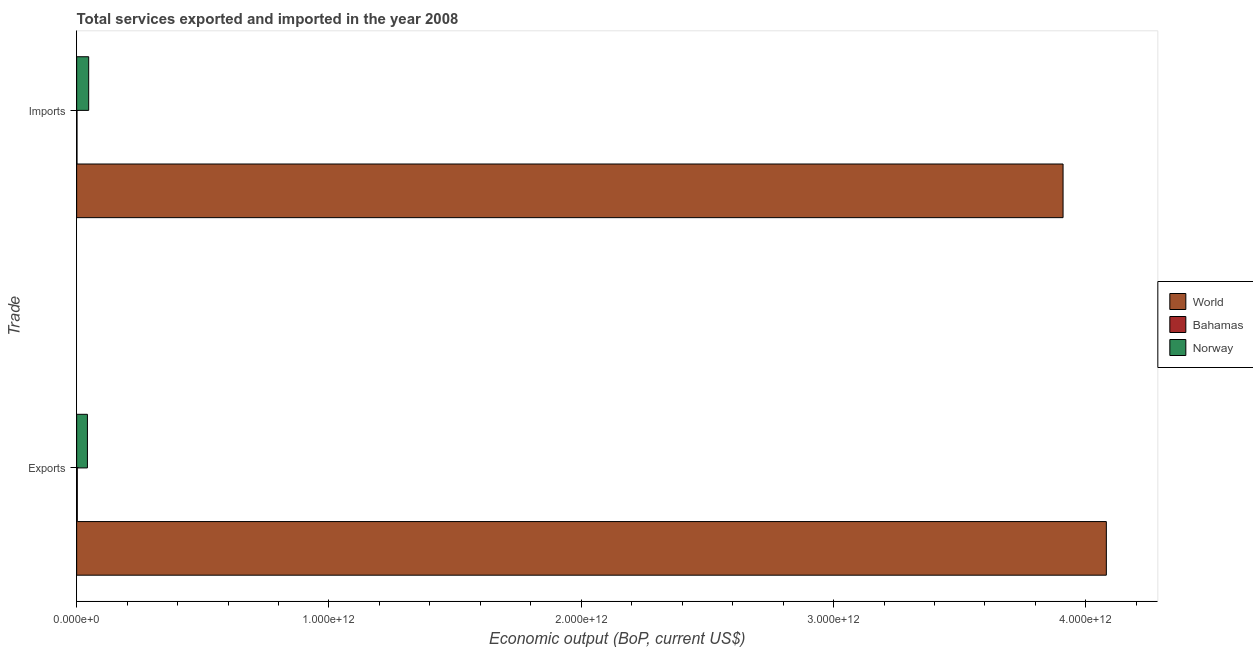Are the number of bars per tick equal to the number of legend labels?
Offer a very short reply. Yes. How many bars are there on the 2nd tick from the top?
Ensure brevity in your answer.  3. How many bars are there on the 2nd tick from the bottom?
Your answer should be compact. 3. What is the label of the 2nd group of bars from the top?
Offer a very short reply. Exports. What is the amount of service exports in World?
Your response must be concise. 4.08e+12. Across all countries, what is the maximum amount of service imports?
Your answer should be very brief. 3.91e+12. Across all countries, what is the minimum amount of service exports?
Offer a very short reply. 2.53e+09. In which country was the amount of service imports minimum?
Make the answer very short. Bahamas. What is the total amount of service exports in the graph?
Your response must be concise. 4.13e+12. What is the difference between the amount of service imports in Bahamas and that in World?
Provide a succinct answer. -3.91e+12. What is the difference between the amount of service exports in Bahamas and the amount of service imports in World?
Keep it short and to the point. -3.91e+12. What is the average amount of service imports per country?
Offer a very short reply. 1.32e+12. What is the difference between the amount of service exports and amount of service imports in Norway?
Your response must be concise. -5.07e+09. In how many countries, is the amount of service exports greater than 2800000000000 US$?
Your answer should be very brief. 1. What is the ratio of the amount of service exports in Norway to that in World?
Ensure brevity in your answer.  0.01. What does the 3rd bar from the top in Imports represents?
Offer a terse response. World. How many bars are there?
Your answer should be compact. 6. What is the difference between two consecutive major ticks on the X-axis?
Your answer should be very brief. 1.00e+12. Are the values on the major ticks of X-axis written in scientific E-notation?
Your answer should be compact. Yes. Does the graph contain grids?
Ensure brevity in your answer.  No. How many legend labels are there?
Make the answer very short. 3. How are the legend labels stacked?
Make the answer very short. Vertical. What is the title of the graph?
Provide a short and direct response. Total services exported and imported in the year 2008. Does "Montenegro" appear as one of the legend labels in the graph?
Your answer should be compact. No. What is the label or title of the X-axis?
Keep it short and to the point. Economic output (BoP, current US$). What is the label or title of the Y-axis?
Keep it short and to the point. Trade. What is the Economic output (BoP, current US$) in World in Exports?
Your response must be concise. 4.08e+12. What is the Economic output (BoP, current US$) of Bahamas in Exports?
Keep it short and to the point. 2.53e+09. What is the Economic output (BoP, current US$) of Norway in Exports?
Offer a very short reply. 4.26e+1. What is the Economic output (BoP, current US$) of World in Imports?
Your answer should be compact. 3.91e+12. What is the Economic output (BoP, current US$) in Bahamas in Imports?
Make the answer very short. 1.40e+09. What is the Economic output (BoP, current US$) of Norway in Imports?
Offer a terse response. 4.77e+1. Across all Trade, what is the maximum Economic output (BoP, current US$) of World?
Keep it short and to the point. 4.08e+12. Across all Trade, what is the maximum Economic output (BoP, current US$) of Bahamas?
Your answer should be very brief. 2.53e+09. Across all Trade, what is the maximum Economic output (BoP, current US$) in Norway?
Your answer should be very brief. 4.77e+1. Across all Trade, what is the minimum Economic output (BoP, current US$) in World?
Give a very brief answer. 3.91e+12. Across all Trade, what is the minimum Economic output (BoP, current US$) of Bahamas?
Make the answer very short. 1.40e+09. Across all Trade, what is the minimum Economic output (BoP, current US$) of Norway?
Offer a terse response. 4.26e+1. What is the total Economic output (BoP, current US$) in World in the graph?
Keep it short and to the point. 7.99e+12. What is the total Economic output (BoP, current US$) of Bahamas in the graph?
Offer a very short reply. 3.94e+09. What is the total Economic output (BoP, current US$) of Norway in the graph?
Offer a very short reply. 9.03e+1. What is the difference between the Economic output (BoP, current US$) of World in Exports and that in Imports?
Give a very brief answer. 1.72e+11. What is the difference between the Economic output (BoP, current US$) of Bahamas in Exports and that in Imports?
Ensure brevity in your answer.  1.13e+09. What is the difference between the Economic output (BoP, current US$) of Norway in Exports and that in Imports?
Offer a very short reply. -5.07e+09. What is the difference between the Economic output (BoP, current US$) in World in Exports and the Economic output (BoP, current US$) in Bahamas in Imports?
Keep it short and to the point. 4.08e+12. What is the difference between the Economic output (BoP, current US$) in World in Exports and the Economic output (BoP, current US$) in Norway in Imports?
Make the answer very short. 4.03e+12. What is the difference between the Economic output (BoP, current US$) of Bahamas in Exports and the Economic output (BoP, current US$) of Norway in Imports?
Provide a short and direct response. -4.52e+1. What is the average Economic output (BoP, current US$) of World per Trade?
Ensure brevity in your answer.  4.00e+12. What is the average Economic output (BoP, current US$) in Bahamas per Trade?
Keep it short and to the point. 1.97e+09. What is the average Economic output (BoP, current US$) in Norway per Trade?
Ensure brevity in your answer.  4.52e+1. What is the difference between the Economic output (BoP, current US$) in World and Economic output (BoP, current US$) in Bahamas in Exports?
Offer a very short reply. 4.08e+12. What is the difference between the Economic output (BoP, current US$) in World and Economic output (BoP, current US$) in Norway in Exports?
Ensure brevity in your answer.  4.04e+12. What is the difference between the Economic output (BoP, current US$) of Bahamas and Economic output (BoP, current US$) of Norway in Exports?
Give a very brief answer. -4.01e+1. What is the difference between the Economic output (BoP, current US$) in World and Economic output (BoP, current US$) in Bahamas in Imports?
Your answer should be very brief. 3.91e+12. What is the difference between the Economic output (BoP, current US$) in World and Economic output (BoP, current US$) in Norway in Imports?
Make the answer very short. 3.86e+12. What is the difference between the Economic output (BoP, current US$) in Bahamas and Economic output (BoP, current US$) in Norway in Imports?
Your answer should be very brief. -4.63e+1. What is the ratio of the Economic output (BoP, current US$) of World in Exports to that in Imports?
Offer a terse response. 1.04. What is the ratio of the Economic output (BoP, current US$) in Bahamas in Exports to that in Imports?
Your response must be concise. 1.81. What is the ratio of the Economic output (BoP, current US$) in Norway in Exports to that in Imports?
Provide a succinct answer. 0.89. What is the difference between the highest and the second highest Economic output (BoP, current US$) in World?
Ensure brevity in your answer.  1.72e+11. What is the difference between the highest and the second highest Economic output (BoP, current US$) of Bahamas?
Your answer should be compact. 1.13e+09. What is the difference between the highest and the second highest Economic output (BoP, current US$) in Norway?
Your answer should be very brief. 5.07e+09. What is the difference between the highest and the lowest Economic output (BoP, current US$) in World?
Offer a very short reply. 1.72e+11. What is the difference between the highest and the lowest Economic output (BoP, current US$) in Bahamas?
Keep it short and to the point. 1.13e+09. What is the difference between the highest and the lowest Economic output (BoP, current US$) of Norway?
Your answer should be compact. 5.07e+09. 